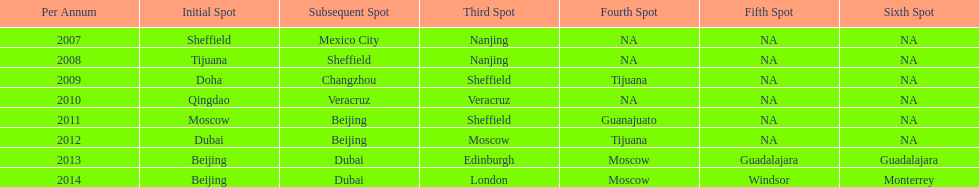Can you parse all the data within this table? {'header': ['Per Annum', 'Initial Spot', 'Subsequent Spot', 'Third Spot', 'Fourth Spot', 'Fifth Spot', 'Sixth Spot'], 'rows': [['2007', 'Sheffield', 'Mexico City', 'Nanjing', 'NA', 'NA', 'NA'], ['2008', 'Tijuana', 'Sheffield', 'Nanjing', 'NA', 'NA', 'NA'], ['2009', 'Doha', 'Changzhou', 'Sheffield', 'Tijuana', 'NA', 'NA'], ['2010', 'Qingdao', 'Veracruz', 'Veracruz', 'NA', 'NA', 'NA'], ['2011', 'Moscow', 'Beijing', 'Sheffield', 'Guanajuato', 'NA', 'NA'], ['2012', 'Dubai', 'Beijing', 'Moscow', 'Tijuana', 'NA', 'NA'], ['2013', 'Beijing', 'Dubai', 'Edinburgh', 'Moscow', 'Guadalajara', 'Guadalajara'], ['2014', 'Beijing', 'Dubai', 'London', 'Moscow', 'Windsor', 'Monterrey']]} How long, in years, has the this world series been occurring? 7 years. 